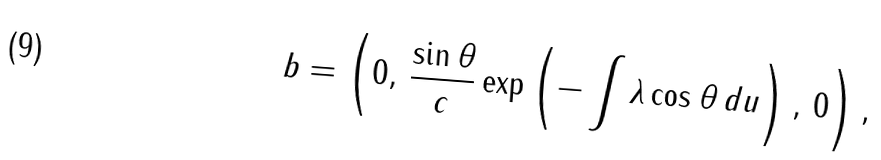Convert formula to latex. <formula><loc_0><loc_0><loc_500><loc_500>b = \left ( 0 , \, \frac { \sin \theta } { c } \exp \left ( - \int \lambda \cos \theta \, d u \right ) , \, 0 \right ) ,</formula> 